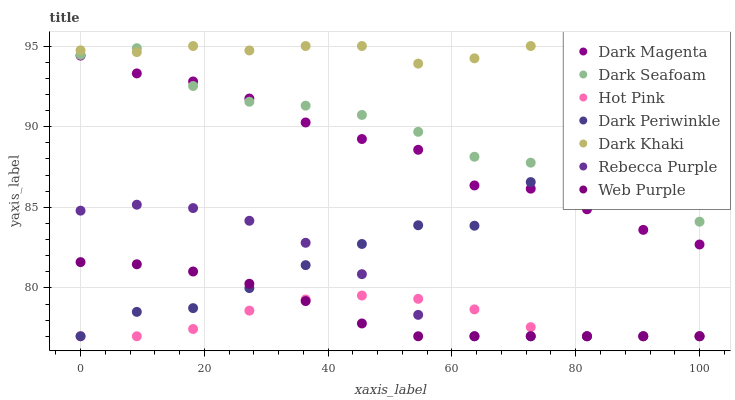Does Hot Pink have the minimum area under the curve?
Answer yes or no. Yes. Does Dark Khaki have the maximum area under the curve?
Answer yes or no. Yes. Does Web Purple have the minimum area under the curve?
Answer yes or no. No. Does Web Purple have the maximum area under the curve?
Answer yes or no. No. Is Web Purple the smoothest?
Answer yes or no. Yes. Is Dark Seafoam the roughest?
Answer yes or no. Yes. Is Hot Pink the smoothest?
Answer yes or no. No. Is Hot Pink the roughest?
Answer yes or no. No. Does Hot Pink have the lowest value?
Answer yes or no. Yes. Does Dark Khaki have the lowest value?
Answer yes or no. No. Does Dark Khaki have the highest value?
Answer yes or no. Yes. Does Web Purple have the highest value?
Answer yes or no. No. Is Hot Pink less than Dark Seafoam?
Answer yes or no. Yes. Is Dark Khaki greater than Rebecca Purple?
Answer yes or no. Yes. Does Dark Seafoam intersect Dark Khaki?
Answer yes or no. Yes. Is Dark Seafoam less than Dark Khaki?
Answer yes or no. No. Is Dark Seafoam greater than Dark Khaki?
Answer yes or no. No. Does Hot Pink intersect Dark Seafoam?
Answer yes or no. No. 